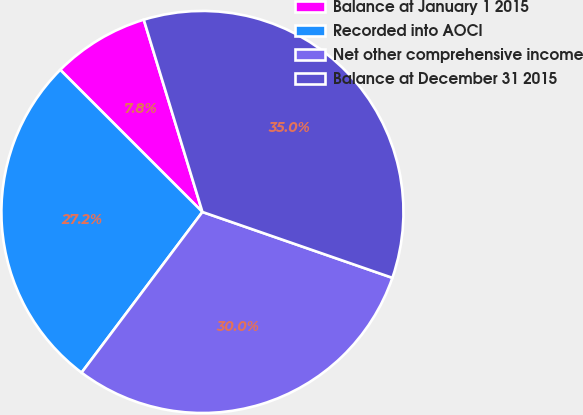Convert chart. <chart><loc_0><loc_0><loc_500><loc_500><pie_chart><fcel>Balance at January 1 2015<fcel>Recorded into AOCI<fcel>Net other comprehensive income<fcel>Balance at December 31 2015<nl><fcel>7.79%<fcel>27.23%<fcel>29.95%<fcel>35.02%<nl></chart> 